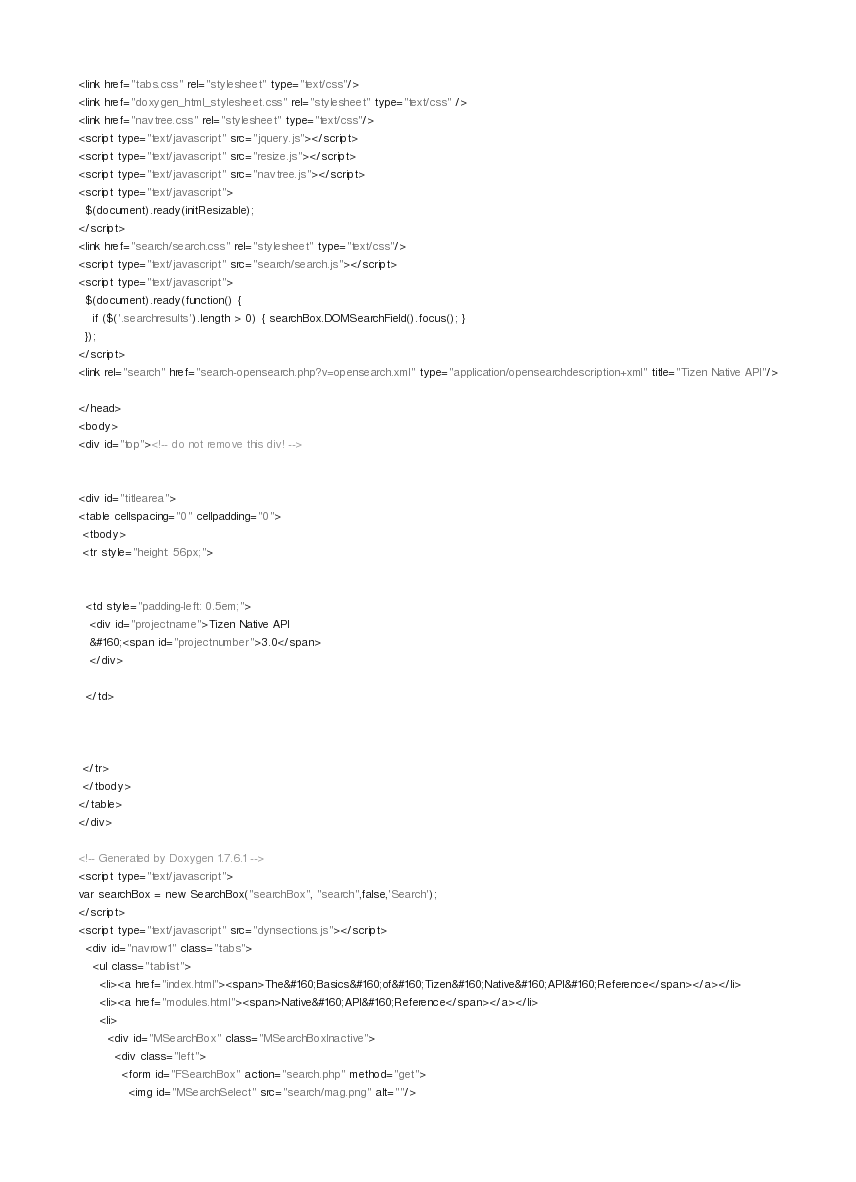Convert code to text. <code><loc_0><loc_0><loc_500><loc_500><_HTML_><link href="tabs.css" rel="stylesheet" type="text/css"/>
<link href="doxygen_html_stylesheet.css" rel="stylesheet" type="text/css" />
<link href="navtree.css" rel="stylesheet" type="text/css"/>
<script type="text/javascript" src="jquery.js"></script>
<script type="text/javascript" src="resize.js"></script>
<script type="text/javascript" src="navtree.js"></script>
<script type="text/javascript">
  $(document).ready(initResizable);
</script>
<link href="search/search.css" rel="stylesheet" type="text/css"/>
<script type="text/javascript" src="search/search.js"></script>
<script type="text/javascript">
  $(document).ready(function() {
    if ($('.searchresults').length > 0) { searchBox.DOMSearchField().focus(); }
  });
</script>
<link rel="search" href="search-opensearch.php?v=opensearch.xml" type="application/opensearchdescription+xml" title="Tizen Native API"/>

</head>
<body>
<div id="top"><!-- do not remove this div! -->


<div id="titlearea">
<table cellspacing="0" cellpadding="0">
 <tbody>
 <tr style="height: 56px;">
  
  
  <td style="padding-left: 0.5em;">
   <div id="projectname">Tizen Native API
   &#160;<span id="projectnumber">3.0</span>
   </div>
   
  </td>
  
  
  
 </tr>
 </tbody>
</table>
</div>

<!-- Generated by Doxygen 1.7.6.1 -->
<script type="text/javascript">
var searchBox = new SearchBox("searchBox", "search",false,'Search');
</script>
<script type="text/javascript" src="dynsections.js"></script>
  <div id="navrow1" class="tabs">
    <ul class="tablist">
      <li><a href="index.html"><span>The&#160;Basics&#160;of&#160;Tizen&#160;Native&#160;API&#160;Reference</span></a></li>
      <li><a href="modules.html"><span>Native&#160;API&#160;Reference</span></a></li>
      <li>
        <div id="MSearchBox" class="MSearchBoxInactive">
          <div class="left">
            <form id="FSearchBox" action="search.php" method="get">
              <img id="MSearchSelect" src="search/mag.png" alt=""/></code> 